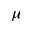<formula> <loc_0><loc_0><loc_500><loc_500>\mu</formula> 